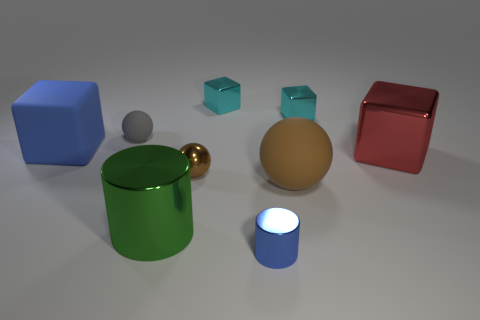Add 1 blue blocks. How many objects exist? 10 Subtract all cylinders. How many objects are left? 7 Subtract all blue cylinders. Subtract all large metallic cylinders. How many objects are left? 7 Add 2 small brown metal balls. How many small brown metal balls are left? 3 Add 7 big red shiny blocks. How many big red shiny blocks exist? 8 Subtract 0 red cylinders. How many objects are left? 9 